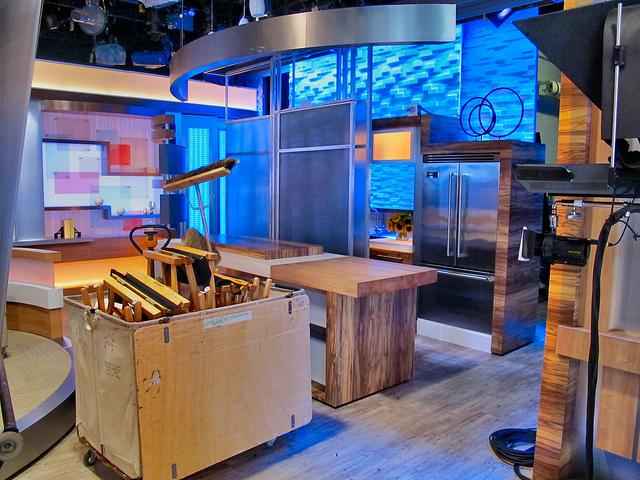What is the floor made of?
Concise answer only. Wood. Is this a TV set?
Write a very short answer. No. What color is on the back wall?
Be succinct. Blue. 